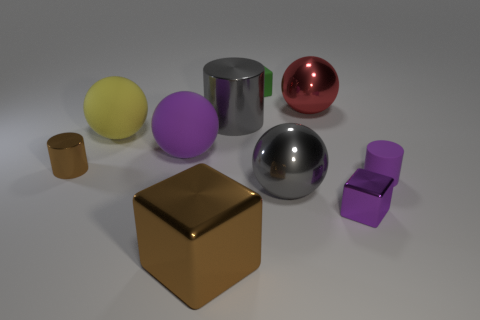Subtract 2 spheres. How many spheres are left? 2 Subtract all purple spheres. How many spheres are left? 3 Subtract all blue spheres. Subtract all gray blocks. How many spheres are left? 4 Subtract all spheres. How many objects are left? 6 Add 1 large cyan shiny spheres. How many large cyan shiny spheres exist? 1 Subtract 1 purple spheres. How many objects are left? 9 Subtract all large matte things. Subtract all tiny matte things. How many objects are left? 6 Add 5 gray balls. How many gray balls are left? 6 